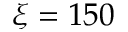<formula> <loc_0><loc_0><loc_500><loc_500>\xi = 1 5 0</formula> 